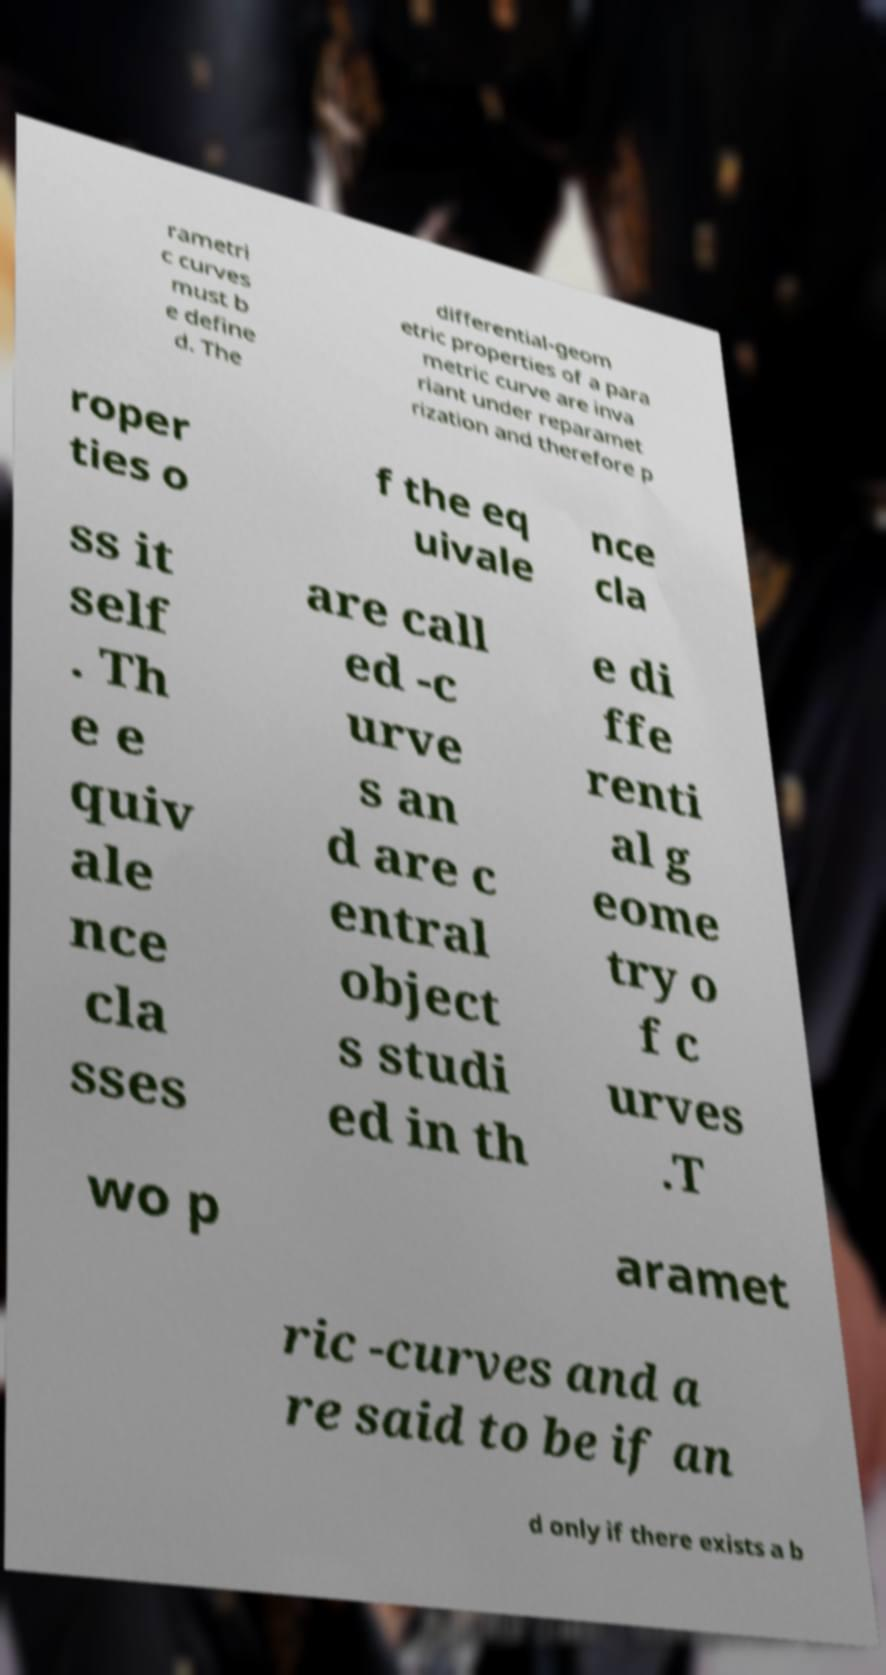Please identify and transcribe the text found in this image. rametri c curves must b e define d. The differential-geom etric properties of a para metric curve are inva riant under reparamet rization and therefore p roper ties o f the eq uivale nce cla ss it self . Th e e quiv ale nce cla sses are call ed -c urve s an d are c entral object s studi ed in th e di ffe renti al g eome try o f c urves .T wo p aramet ric -curves and a re said to be if an d only if there exists a b 